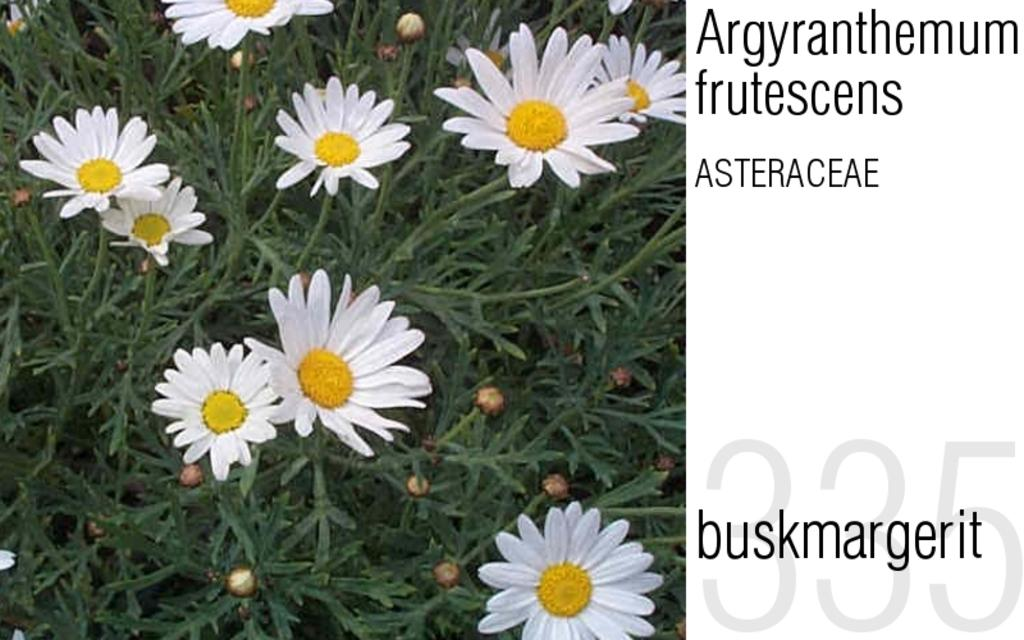What type of living organisms are in the image? There are plants in the image. What color are the flowers on the plants? The flowers on the plants are white. What can be seen written beside the plants? There is something written beside the plants. What type of metal is present in the image? There is no metal present in the image; it features plants with white flowers and writing beside them. What type of harmony is being depicted in the image? The image does not depict any type of harmony; it simply shows plants with white flowers and writing beside them. 